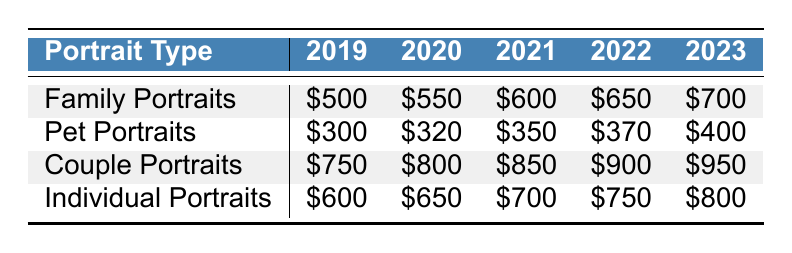What was the average budget allocation for pet portraits in 2021? The average budget allocation for pet portraits in 2021 can be found directly in the corresponding row and column. It is listed as $350.
Answer: $350 Which type of portrait had the highest budget allocation in 2023? To determine which type of portrait had the highest budget allocation in 2023, we can compare the values for each type in that year. The highest value is for couple portraits at $950.
Answer: Couple portraits What was the increase in budget allocation for family portraits from 2019 to 2023? To find the increase in budget allocation for family portraits, we subtract the value in 2019 from that in 2023: $700 (2023) - $500 (2019) = $200.
Answer: $200 Did the budget allocation for individual portraits increase every year? By checking the values for individual portraits from 2019 to 2023, we see that it increased each year: $600, $650, $700, $750, and $800. Therefore, the statement is true.
Answer: Yes What is the total average budget allocation for all portrait types in 2022? First, we need to sum the budget allocations for each type: $650 (family) + $370 (pet) + $900 (couple) + $750 (individual) = $2,670. Then, we see there are four types, so we divide by 4 to get an average: $2,670 / 4 = $667.50.
Answer: $667.50 What is the difference in budget allocation for couple portraits between 2019 and 2022? To find the difference, we subtract the budget for couple portraits in 2019 from that in 2022: $900 (2022) - $750 (2019) = $150.
Answer: $150 Which portrait type showed the smallest increase in budget allocation from 2022 to 2023? We compare the increases for each portrait type from 2022 to 2023: Family ($700 - $650 = $50), Pet ($400 - $370 = $30), Couple ($950 - $900 = $50), Individual ($800 - $750 = $50). The smallest increase is for pet portraits, which increased by $30.
Answer: Pet portraits What was the average budget allocation for all types of portraits in 2023? To find the average for 2023, we sum the values for all portrait types: $700 + $400 + $950 + $800 = $2,850. Then, we divide by 4 (the number of portrait types) to get the average: $2,850 / 4 = $712.50.
Answer: $712.50 Is the average budget allocation for family portraits greater than $600 in the last five years? By looking at the values for family portraits in each year, they are $500, $550, $600, $650, and $700. The average of these is $610, which is greater than $600, so the statement is true.
Answer: Yes What was the overall trend for budget allocation for portraits from 2019 to 2023? The data shows that for every type of portrait, the budget allocation has consistently increased each year without any decreases. Thus, the overall trend is an increasing one.
Answer: Increasing 